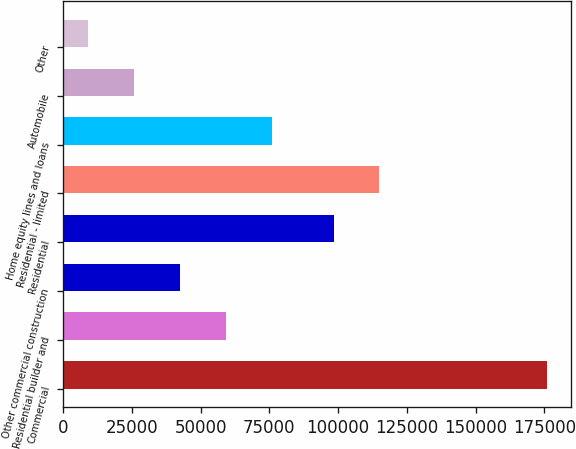Convert chart to OTSL. <chart><loc_0><loc_0><loc_500><loc_500><bar_chart><fcel>Commercial<fcel>Residential builder and<fcel>Other commercial construction<fcel>Residential<fcel>Residential - limited<fcel>Home equity lines and loans<fcel>Automobile<fcel>Other<nl><fcel>175877<fcel>59215.7<fcel>42549.8<fcel>98394<fcel>115060<fcel>75881.6<fcel>25883.9<fcel>9218<nl></chart> 